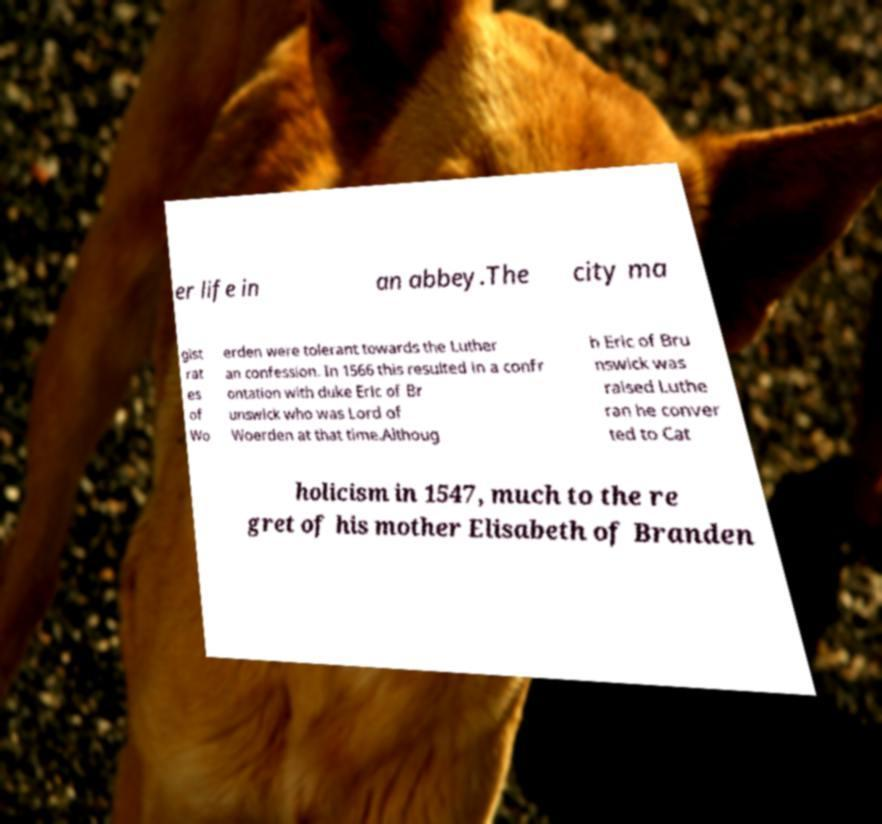Could you extract and type out the text from this image? er life in an abbey.The city ma gist rat es of Wo erden were tolerant towards the Luther an confession. In 1566 this resulted in a confr ontation with duke Eric of Br unswick who was Lord of Woerden at that time.Althoug h Eric of Bru nswick was raised Luthe ran he conver ted to Cat holicism in 1547, much to the re gret of his mother Elisabeth of Branden 